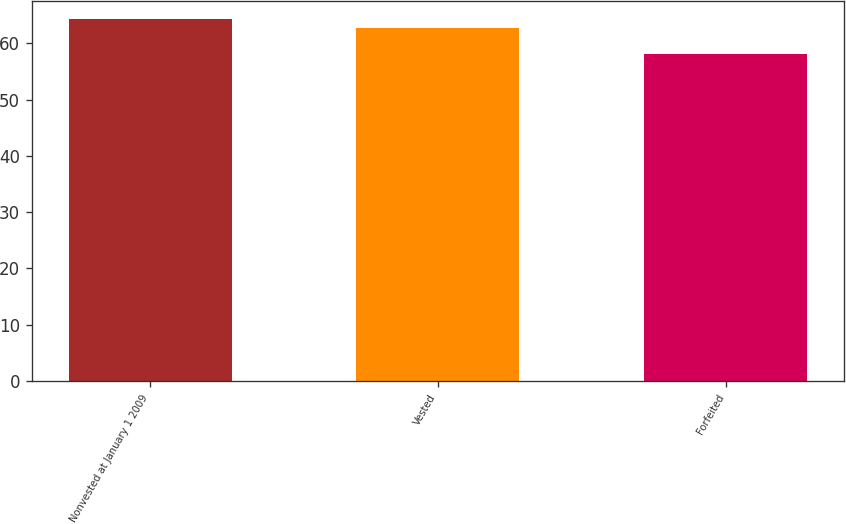Convert chart to OTSL. <chart><loc_0><loc_0><loc_500><loc_500><bar_chart><fcel>Nonvested at January 1 2009<fcel>Vested<fcel>Forfeited<nl><fcel>64.37<fcel>62.76<fcel>58.09<nl></chart> 